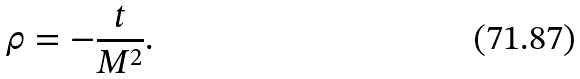Convert formula to latex. <formula><loc_0><loc_0><loc_500><loc_500>\rho = - \frac { t } { M ^ { 2 } } .</formula> 